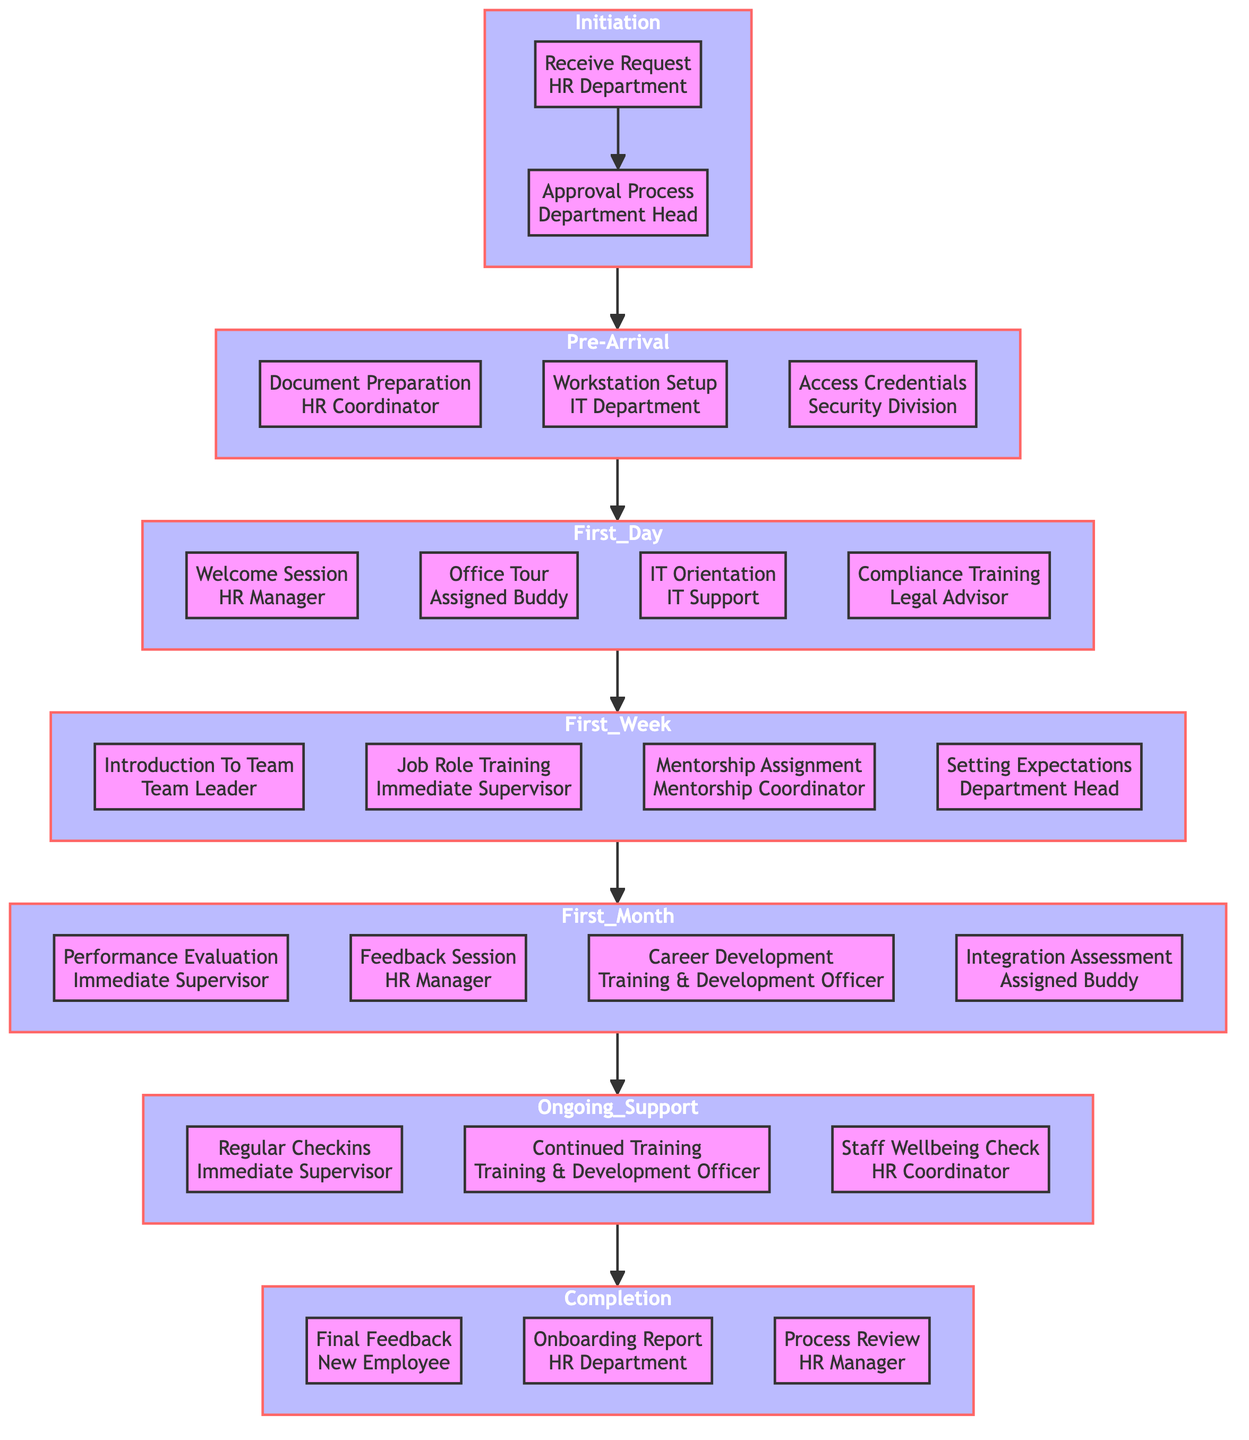What is the first step in the workflow? The workflow begins with the "Receive Request" step, which is handled by the HR Department. This is the first node in the "Initiation" phase.
Answer: Receive Request Who prepares the documents during the Pre-Arrival phase? The "Document Preparation" is the responsibility of the HR Coordinator, as indicated in the Pre-Arrival section of the diagram.
Answer: HR Coordinator How many main phases are there in the workflow? The diagram shows a total of six main phases: Initiation, Pre-Arrival, First Day, First Week, First Month, Ongoing Support, and Completion. Counting these phases gives a total of six.
Answer: 6 What is the role of the "IT Support" during the First Day? The "IT Orientation" is the task assigned to the IT Support as part of the First Day activities, clearly indicated in the First Day section of the diagram.
Answer: IT Orientation Which role conducts the "Performance Evaluation" in the First Month? The "Performance Evaluation" is conducted by the Immediate Supervisor, as specified in the First Month section of the diagram.
Answer: Immediate Supervisor What action follows the "Office Tour" in the First Day phase? After the "Office Tour," the next action is the "IT Orientation," indicating a sequential relationship in the First Day phase. This can be confirmed by the directed flow in the section.
Answer: IT Orientation In which phase does the "Final Feedback" take place? The final feedback occurs in the Completion phase as the last action before concluding the onboarding process, as shown at the end of the flowchart.
Answer: Completion What is the main purpose of the "Ongoing Support" phase? The Ongoing Support phase focuses on regular check-ins, continued training, and checking staff wellbeing, ensuring that the new employee is supported during their transition into the agency.
Answer: Support Which department is responsible for the "Onboarding Report"? The HR Department is responsible for creating the "Onboarding Report," which is outlined as part of the Completion phase in the workflow.
Answer: HR Department 